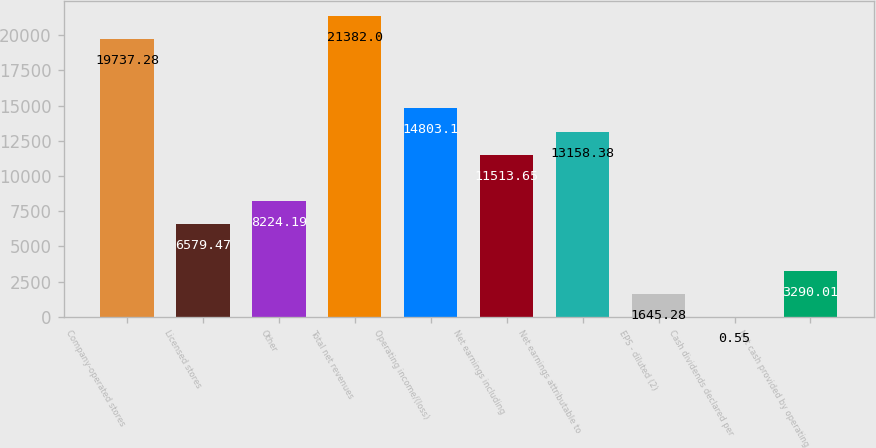Convert chart. <chart><loc_0><loc_0><loc_500><loc_500><bar_chart><fcel>Company-operated stores<fcel>Licensed stores<fcel>Other<fcel>Total net revenues<fcel>Operating income/(loss)<fcel>Net earnings including<fcel>Net earnings attributable to<fcel>EPS - diluted (2)<fcel>Cash dividends declared per<fcel>Net cash provided by operating<nl><fcel>19737.3<fcel>6579.47<fcel>8224.19<fcel>21382<fcel>14803.1<fcel>11513.6<fcel>13158.4<fcel>1645.28<fcel>0.55<fcel>3290.01<nl></chart> 